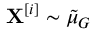Convert formula to latex. <formula><loc_0><loc_0><loc_500><loc_500>X ^ { [ i ] } \sim \tilde { \mu } _ { G }</formula> 